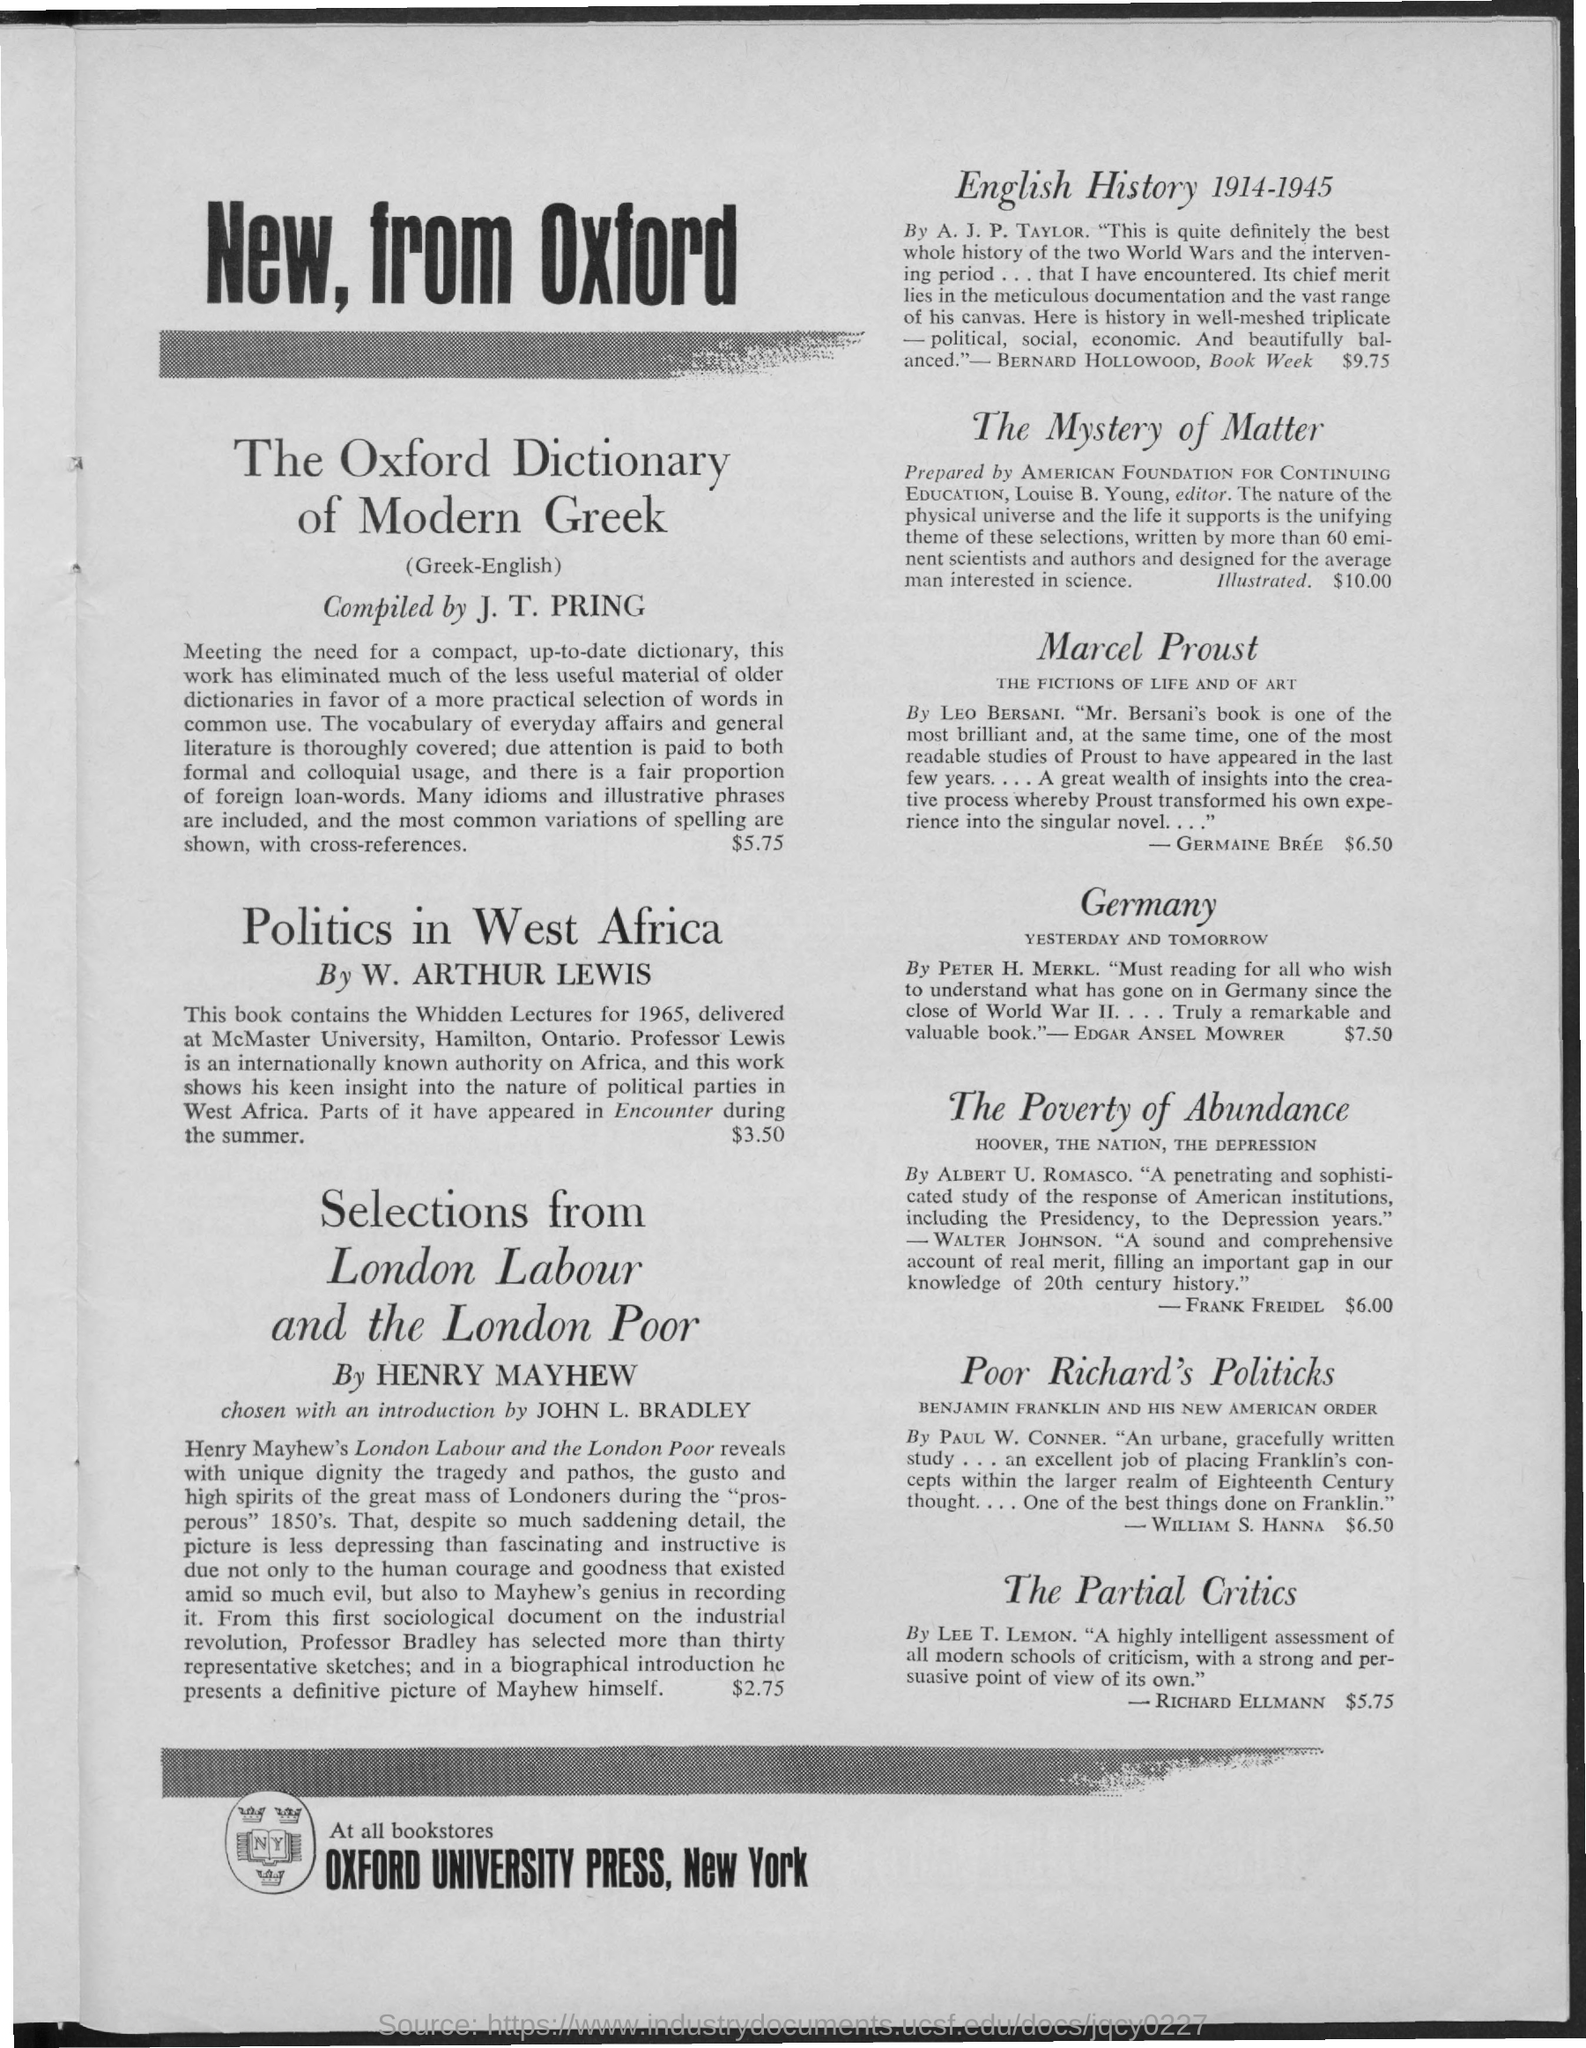Identify some key points in this picture. The cost of politics in West Africa is $3.50. J. T. PRING compiled the Oxford Dictionary of Modern Greek. The book titled "English History 1914-1945" was written by A.J.P. Taylor. Oxford University Press is the press that is mentioned. 